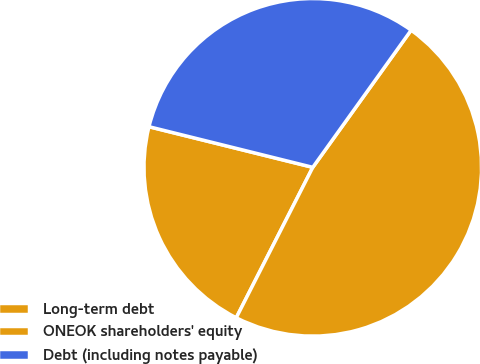Convert chart. <chart><loc_0><loc_0><loc_500><loc_500><pie_chart><fcel>Long-term debt<fcel>ONEOK shareholders' equity<fcel>Debt (including notes payable)<nl><fcel>21.38%<fcel>47.59%<fcel>31.03%<nl></chart> 